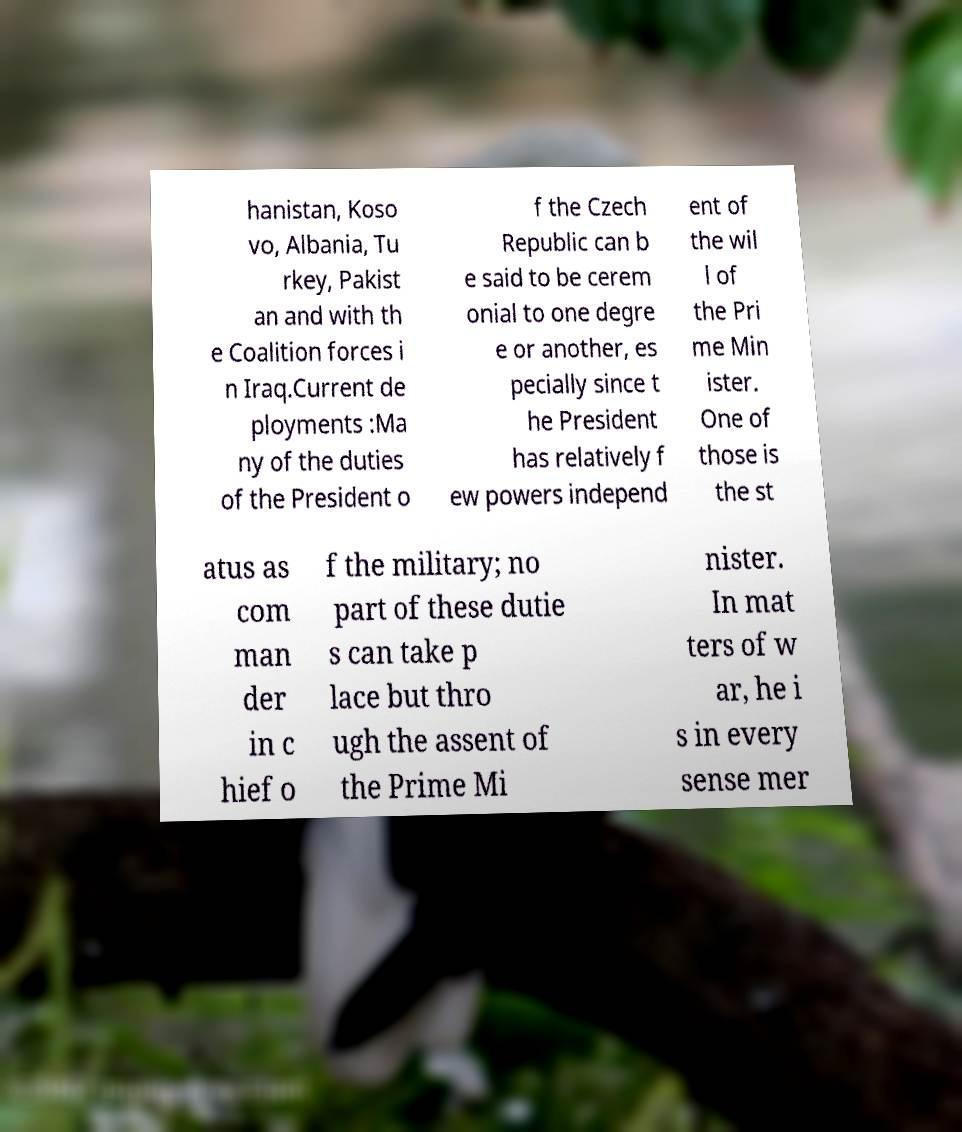Could you extract and type out the text from this image? hanistan, Koso vo, Albania, Tu rkey, Pakist an and with th e Coalition forces i n Iraq.Current de ployments :Ma ny of the duties of the President o f the Czech Republic can b e said to be cerem onial to one degre e or another, es pecially since t he President has relatively f ew powers independ ent of the wil l of the Pri me Min ister. One of those is the st atus as com man der in c hief o f the military; no part of these dutie s can take p lace but thro ugh the assent of the Prime Mi nister. In mat ters of w ar, he i s in every sense mer 